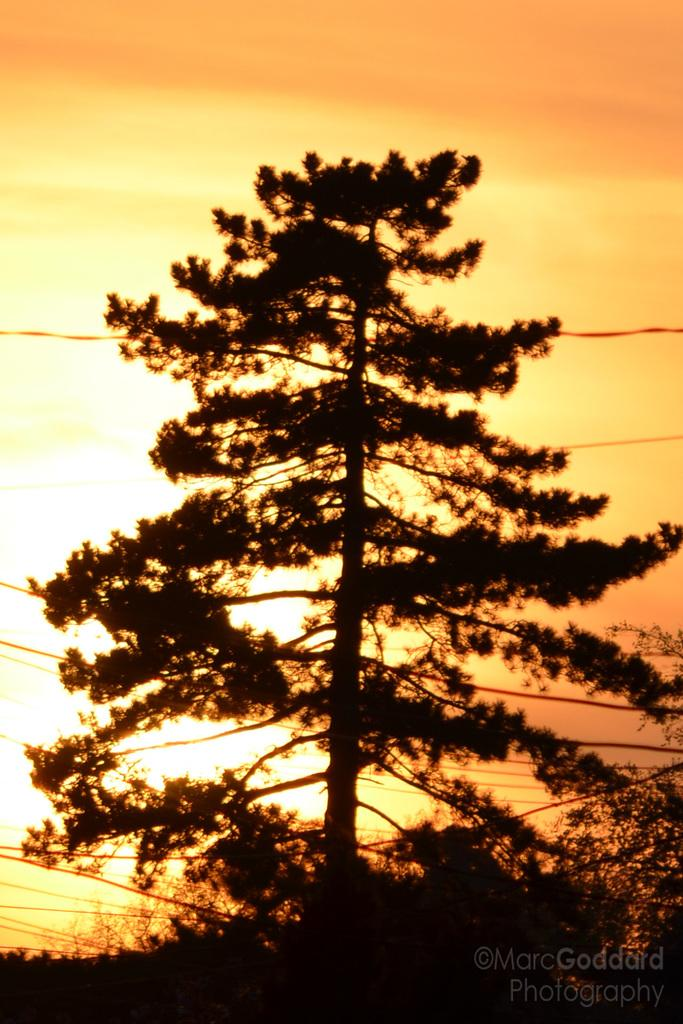What is the main subject in the center of the image? There is a tree in the center of the image. What can be seen in the background of the image? There are wires and sun rays visible in the background of the image. Where is the hydrant located in the image? There is no hydrant present in the image. What type of beef is being cooked in the image? There is no beef present in the image. 